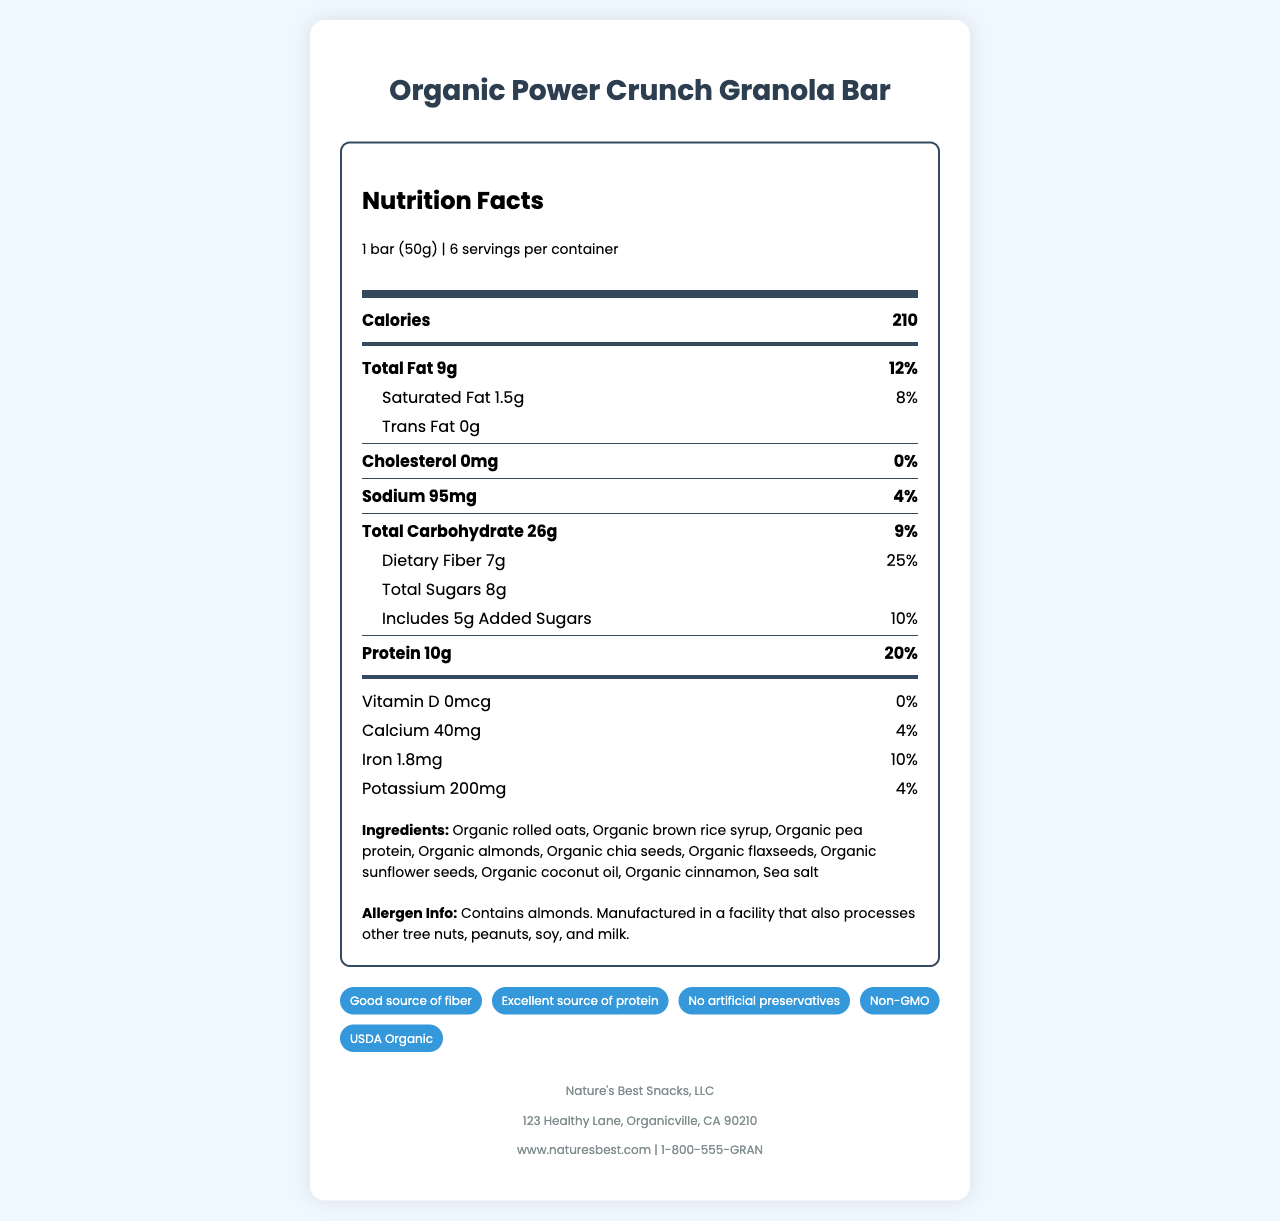how many calories are in one serving? The document directly states that each serving of the Organic Power Crunch Granola Bar contains 210 calories.
Answer: 210 calories what is the total fat content per serving? The document lists the total fat content as 9 grams per serving.
Answer: 9g how much dietary fiber does each bar contain? The document shows that each granola bar contains 7 grams of dietary fiber.
Answer: 7g what is the protein content per bar? According to the document, each bar contains 10 grams of protein.
Answer: 10g what is the daily value percentage for protein per serving? The protein percentage of the daily value for each serving is listed as 20% in the document.
Answer: 20% how many grams of added sugars are there per serving? The document includes information that each serving has 5 grams of added sugars.
Answer: 5g is the granola bar a significant source of calcium? The document states that the granola bar contains 40mg of calcium, contributing only 4% of the daily value, which is relatively low.
Answer: No how many health claims are associated with this product? The document lists five health claims: Good source of fiber, Excellent source of protein, No artificial preservatives, Non-GMO, USDA Organic.
Answer: 5 which allergen is present in this granola bar? The document specifies that the product contains almonds and may also be processed in a facility with other tree nuts, peanuts, soy, and milk.
Answer: Almonds which ingredient is used as a protein source in the granola bar? A. Organic rolled oats B. Organic brown rice syrup C. Organic pea protein D. Organic flaxseeds The document includes organic pea protein as one of the ingredients, which is used as a protein source.
Answer: C how much iron is in one serving of the granola bar? The document specifies that each serving provides 1.8mg of iron.
Answer: 1.8mg what is the serving size of the granola bar? A. 30g B. 40g C. 50g D. 60g The document defines the serving size as 1 bar, which weighs 50 grams.
Answer: C does the granola bar contain any trans fat? The document mentions that the trans fat content is 0 grams per serving.
Answer: No summarize the nutrition facts and main information about the granola bar. The provided summary covers all the key nutritional facts, ingredient details, health claims, and allergen information about the granola bar.
Answer: The Organic Power Crunch Granola Bar has a serving size of 1 bar (50g) with 6 servings per container. Each bar contains 210 calories, 9g of total fat (12% DV), 1.5g of saturated fat (8% DV), 0g trans fat, 0mg cholesterol, 95mg sodium (4% DV), 26g total carbohydrates (9% DV), 7g dietary fiber (25% DV), 8g total sugars including 5g added sugars (10% DV), and 10g protein (20% DV). It also includes 0mcg Vitamin D, 40mg calcium (4% DV), 1.8mg iron (10% DV), and 200mg potassium (4% DV). The ingredients are organic and the product boasts several health claims like being a good source of fiber, an excellent source of protein, free from artificial preservatives, non-GMO, and USDA Organic. It contains almonds and is processed in a facility that also handles other allergens like tree nuts, peanuts, soy, and milk. how long has Nature's Best Snacks, LLC been in business? The document does not provide any details about the history or founding date of Nature's Best Snacks, LLC.
Answer: Not enough information 